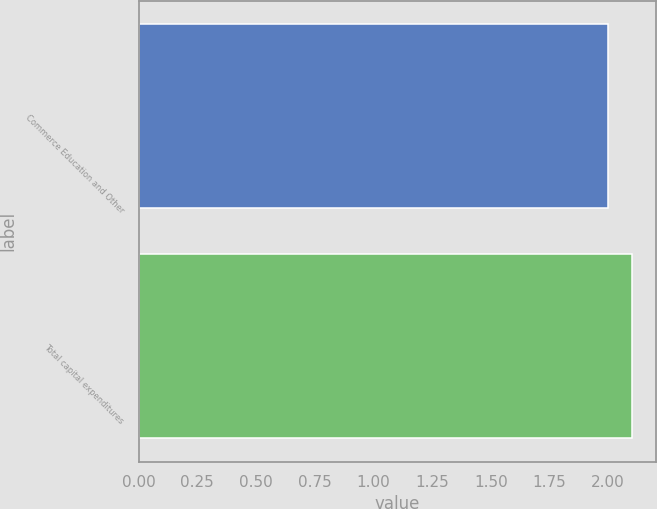<chart> <loc_0><loc_0><loc_500><loc_500><bar_chart><fcel>Commerce Education and Other<fcel>Total capital expenditures<nl><fcel>2<fcel>2.1<nl></chart> 